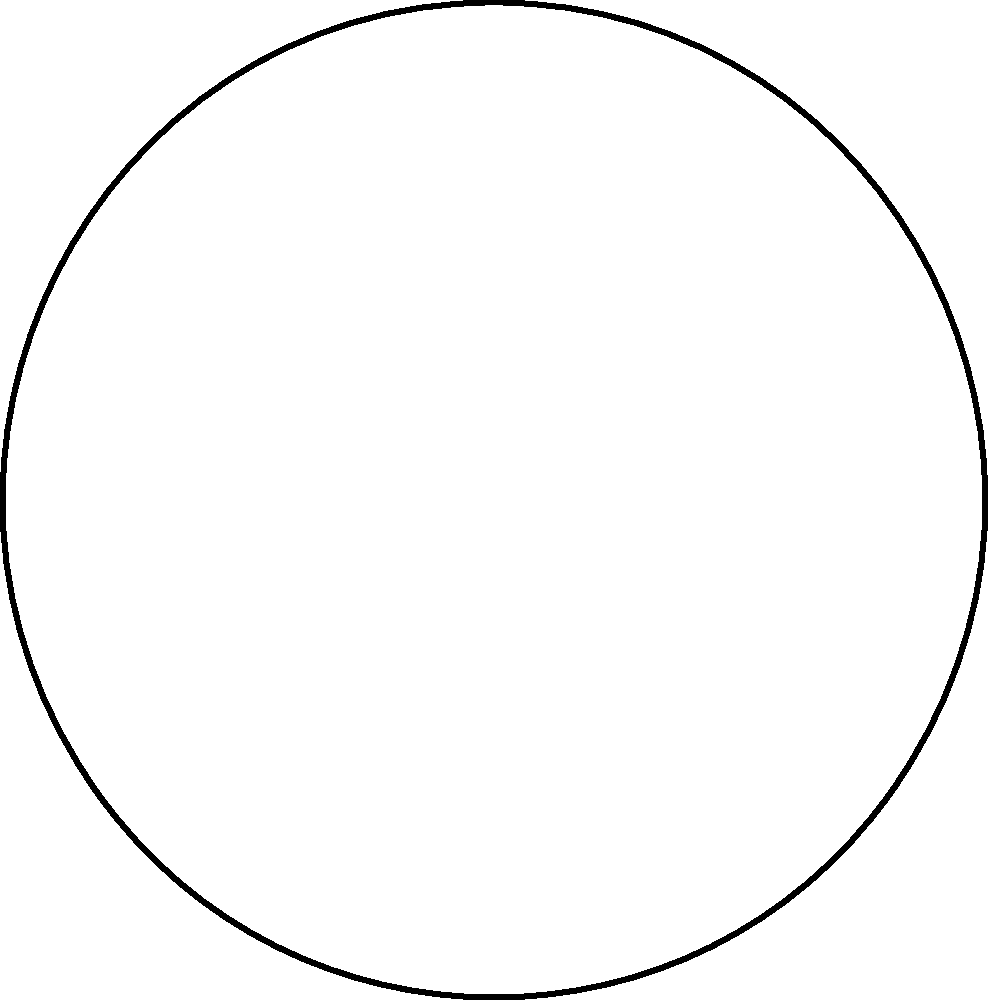In the given character rig setup, which configuration of control points (A, B, and C) would provide the most efficient rigging for smooth deformations and animations? To determine the most efficient rigging setup for smooth deformations and animations, we need to consider the following steps:

1. Analyze the character's structure: The character has a simple, symmetrical shape with two lower points (A and B) and one upper point (C).

2. Consider joint placement: The blue arrows represent the bones or joints of the character, connecting the lower points to the upper point.

3. Evaluate control point placement:
   - Point A controls the left side of the character
   - Point B controls the right side of the character
   - Point C controls the top of the character

4. Assess the rigging hierarchy:
   - Points A and B are at the same level, suggesting they are child joints
   - Point C is positioned above A and B, indicating it could be a parent joint

5. Determine the most efficient setup:
   - Having C as the parent joint with A and B as child joints allows for better control of the overall character movement
   - This setup enables easier creation of poses and animations, as moving C will affect both A and B simultaneously
   - Individual control of A and B allows for fine-tuning of deformations on each side

6. Consider animation workflow:
   - This setup allows animators to quickly create broad movements using C
   - Detailed adjustments can be made using A and B without affecting the overall pose

Therefore, the most efficient rigging setup would be to have C as the parent joint, with A and B as child joints. This configuration provides a balance between overall control and detailed manipulation, leading to smoother deformations and a more efficient animation workflow.
Answer: C as parent, A and B as children 